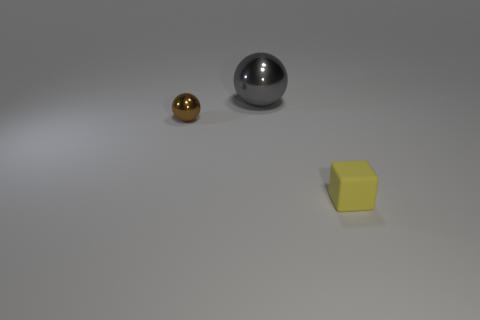Add 2 yellow rubber blocks. How many objects exist? 5 Subtract all gray balls. How many balls are left? 1 Subtract 0 yellow spheres. How many objects are left? 3 Subtract all balls. How many objects are left? 1 Subtract 1 cubes. How many cubes are left? 0 Subtract all blue spheres. Subtract all purple cylinders. How many spheres are left? 2 Subtract all yellow rubber objects. Subtract all small yellow rubber cubes. How many objects are left? 1 Add 2 small brown shiny balls. How many small brown shiny balls are left? 3 Add 2 tiny brown things. How many tiny brown things exist? 3 